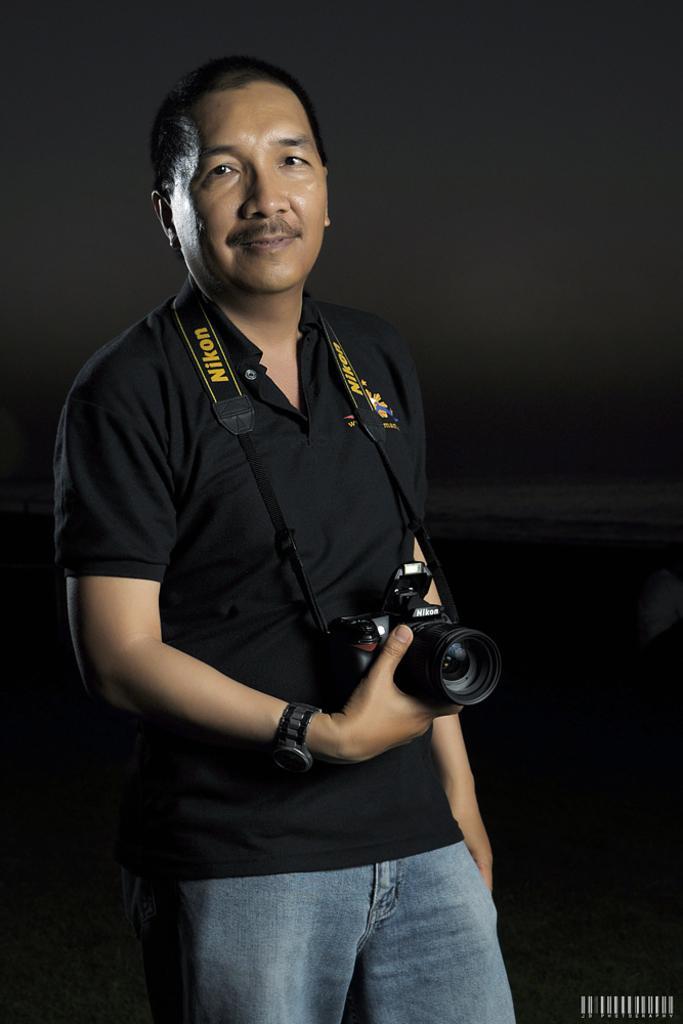Please provide a concise description of this image. In the image we see there is a man who is holding a camera in his hand. 